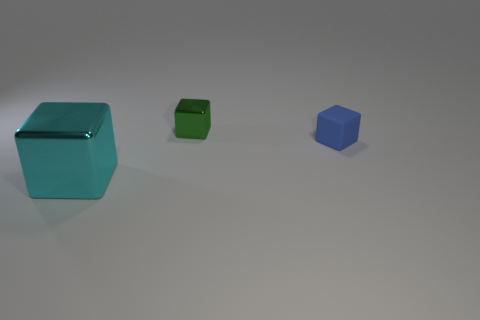What number of other objects are the same size as the green metallic cube?
Your response must be concise. 1. How many blocks are both on the left side of the tiny green cube and behind the big thing?
Ensure brevity in your answer.  0. There is a metal object in front of the tiny blue rubber cube; does it have the same size as the shiny thing that is behind the big block?
Keep it short and to the point. No. There is a cube that is right of the green shiny cube; how big is it?
Your response must be concise. Small. How many objects are shiny blocks that are in front of the small green metal thing or objects that are in front of the green cube?
Offer a very short reply. 2. Is there anything else of the same color as the big shiny thing?
Ensure brevity in your answer.  No. Are there the same number of tiny rubber cubes in front of the large cube and things behind the blue object?
Provide a short and direct response. No. Is the number of cubes that are in front of the green metal block greater than the number of large cyan blocks?
Give a very brief answer. Yes. What number of objects are either cubes behind the rubber thing or big blue metal spheres?
Keep it short and to the point. 1. What number of other tiny blue cubes are made of the same material as the blue cube?
Keep it short and to the point. 0. 